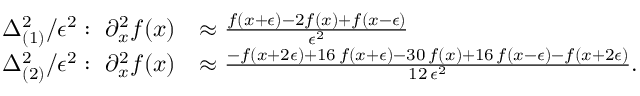<formula> <loc_0><loc_0><loc_500><loc_500>\begin{array} { r l } { \Delta _ { ( 1 ) } ^ { 2 } / \epsilon ^ { 2 } \colon \ \partial _ { x } ^ { 2 } f ( x ) } & { \approx \frac { f ( x + \epsilon ) - 2 f ( x ) + f ( x - \epsilon ) } { \epsilon ^ { 2 } } } \\ { \Delta _ { ( 2 ) } ^ { 2 } / \epsilon ^ { 2 } \colon \ \partial _ { x } ^ { 2 } f ( x ) } & { \approx \frac { - f ( x + 2 \epsilon ) + 1 6 \, f ( x + \epsilon ) - 3 0 \, f ( x ) + 1 6 \, f ( x - \epsilon ) - f ( x + 2 \epsilon ) } { 1 2 \, \epsilon ^ { 2 } } . } \end{array}</formula> 